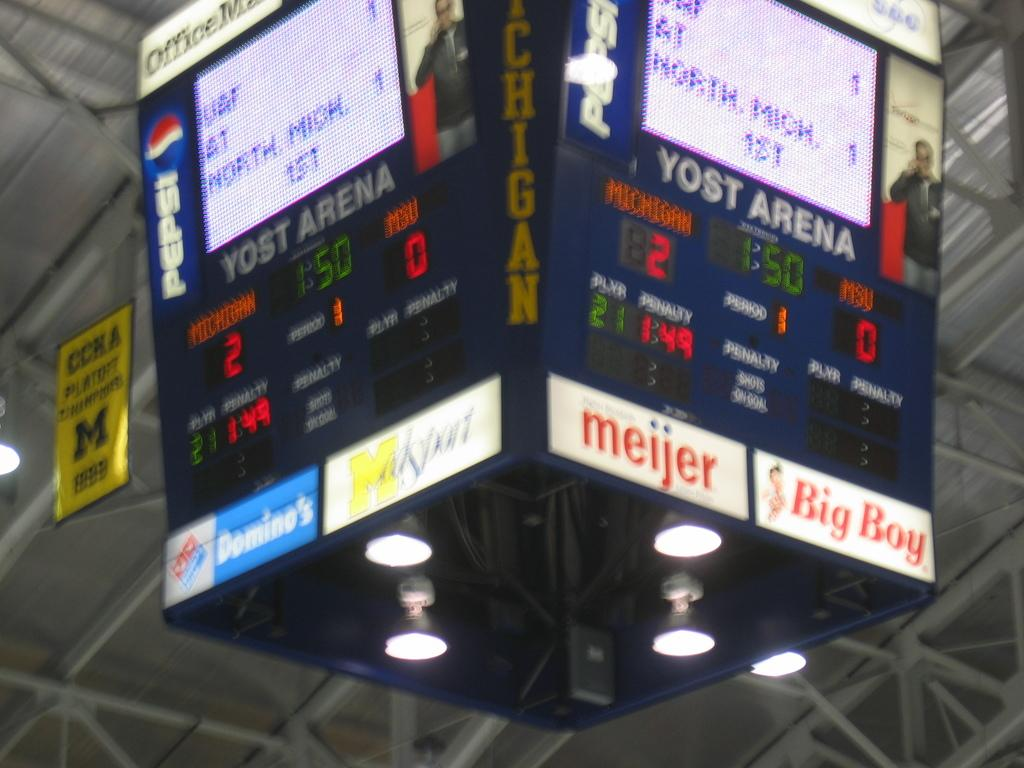<image>
Write a terse but informative summary of the picture. Scoreboard in a sports game that says YOST Arena. 